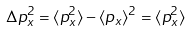Convert formula to latex. <formula><loc_0><loc_0><loc_500><loc_500>\Delta p _ { x } ^ { 2 } = \langle p _ { x } ^ { 2 } \rangle - \langle p _ { x } \rangle ^ { 2 } = \langle p _ { x } ^ { 2 } \rangle</formula> 